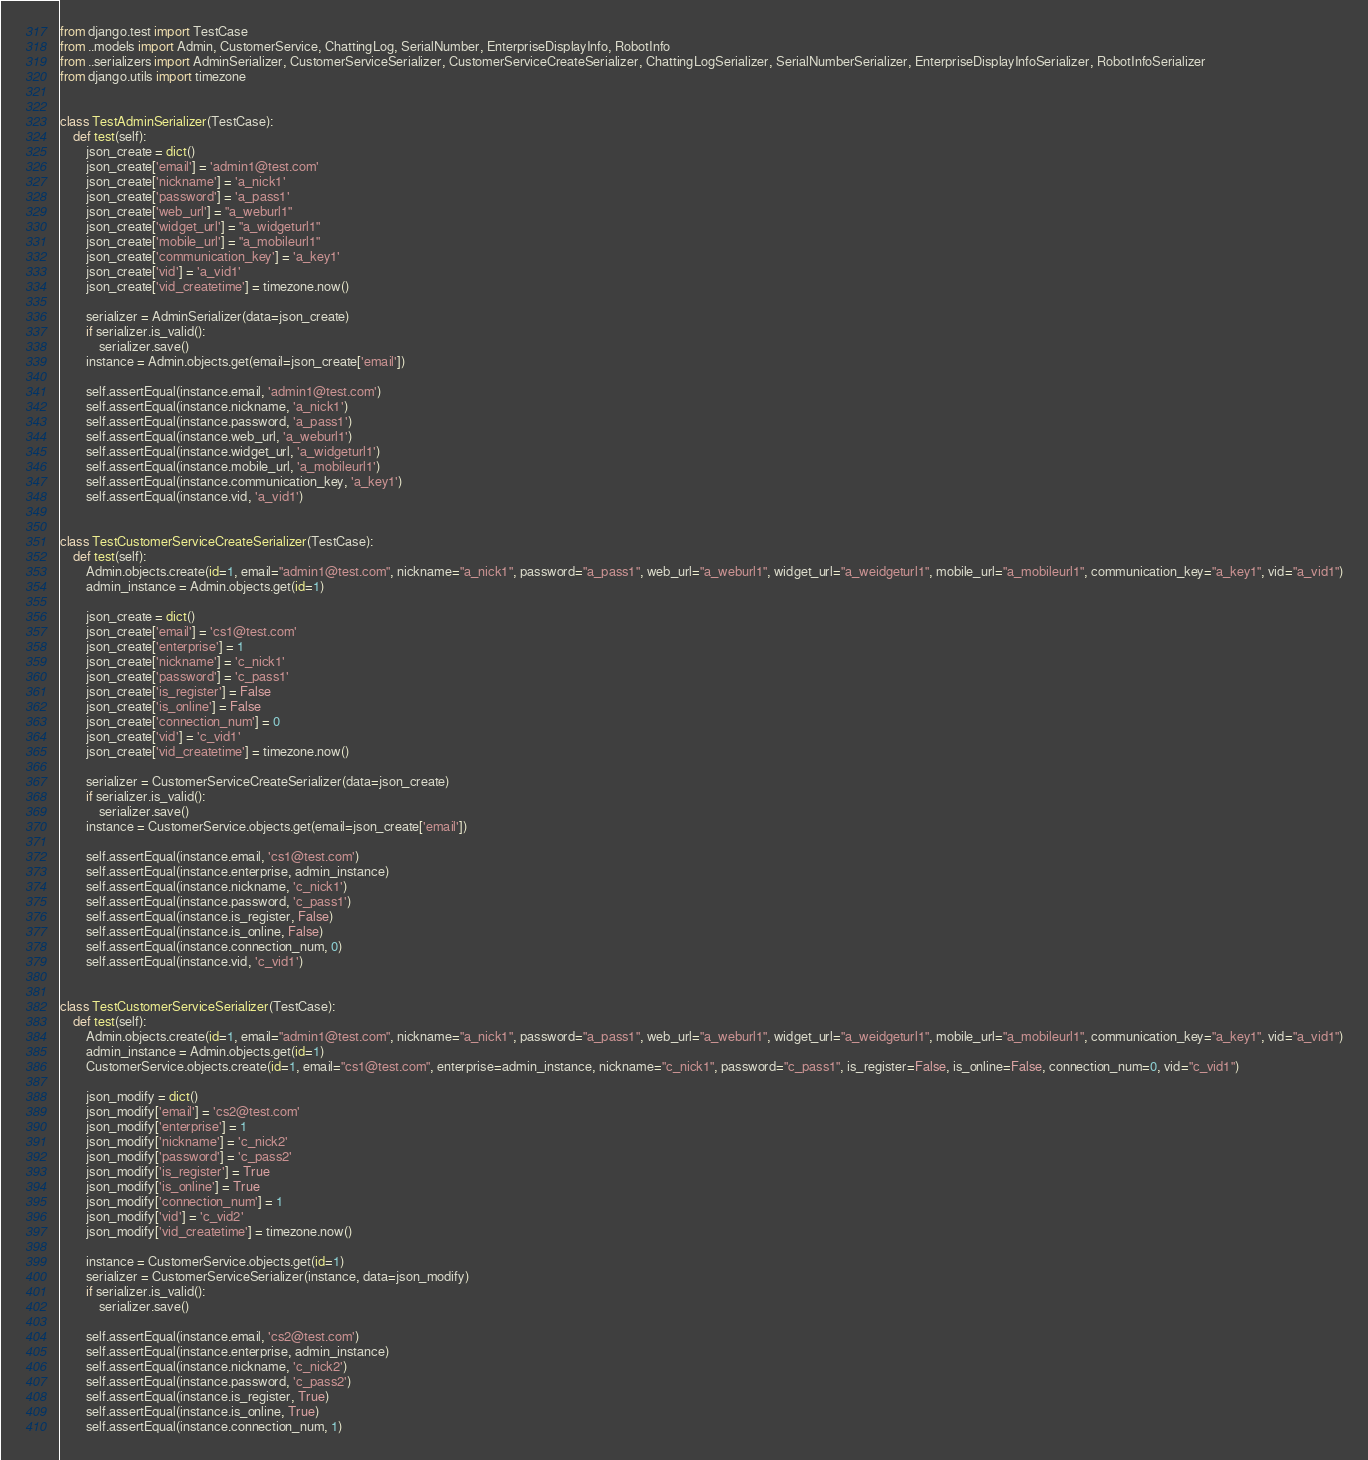<code> <loc_0><loc_0><loc_500><loc_500><_Python_>from django.test import TestCase
from ..models import Admin, CustomerService, ChattingLog, SerialNumber, EnterpriseDisplayInfo, RobotInfo
from ..serializers import AdminSerializer, CustomerServiceSerializer, CustomerServiceCreateSerializer, ChattingLogSerializer, SerialNumberSerializer, EnterpriseDisplayInfoSerializer, RobotInfoSerializer
from django.utils import timezone


class TestAdminSerializer(TestCase):
    def test(self):
        json_create = dict()
        json_create['email'] = 'admin1@test.com'
        json_create['nickname'] = 'a_nick1'
        json_create['password'] = 'a_pass1'
        json_create['web_url'] = "a_weburl1"
        json_create['widget_url'] = "a_widgeturl1"
        json_create['mobile_url'] = "a_mobileurl1"
        json_create['communication_key'] = 'a_key1'
        json_create['vid'] = 'a_vid1'
        json_create['vid_createtime'] = timezone.now()

        serializer = AdminSerializer(data=json_create)
        if serializer.is_valid():
            serializer.save()
        instance = Admin.objects.get(email=json_create['email'])

        self.assertEqual(instance.email, 'admin1@test.com')
        self.assertEqual(instance.nickname, 'a_nick1')
        self.assertEqual(instance.password, 'a_pass1')
        self.assertEqual(instance.web_url, 'a_weburl1')
        self.assertEqual(instance.widget_url, 'a_widgeturl1')
        self.assertEqual(instance.mobile_url, 'a_mobileurl1')
        self.assertEqual(instance.communication_key, 'a_key1')
        self.assertEqual(instance.vid, 'a_vid1')


class TestCustomerServiceCreateSerializer(TestCase):
    def test(self):
        Admin.objects.create(id=1, email="admin1@test.com", nickname="a_nick1", password="a_pass1", web_url="a_weburl1", widget_url="a_weidgeturl1", mobile_url="a_mobileurl1", communication_key="a_key1", vid="a_vid1")
        admin_instance = Admin.objects.get(id=1)

        json_create = dict()
        json_create['email'] = 'cs1@test.com'
        json_create['enterprise'] = 1
        json_create['nickname'] = 'c_nick1'
        json_create['password'] = 'c_pass1'
        json_create['is_register'] = False
        json_create['is_online'] = False
        json_create['connection_num'] = 0
        json_create['vid'] = 'c_vid1'
        json_create['vid_createtime'] = timezone.now()

        serializer = CustomerServiceCreateSerializer(data=json_create)
        if serializer.is_valid():
            serializer.save()
        instance = CustomerService.objects.get(email=json_create['email'])

        self.assertEqual(instance.email, 'cs1@test.com')
        self.assertEqual(instance.enterprise, admin_instance)
        self.assertEqual(instance.nickname, 'c_nick1')
        self.assertEqual(instance.password, 'c_pass1')
        self.assertEqual(instance.is_register, False)
        self.assertEqual(instance.is_online, False)
        self.assertEqual(instance.connection_num, 0)
        self.assertEqual(instance.vid, 'c_vid1')


class TestCustomerServiceSerializer(TestCase):
    def test(self):
        Admin.objects.create(id=1, email="admin1@test.com", nickname="a_nick1", password="a_pass1", web_url="a_weburl1", widget_url="a_weidgeturl1", mobile_url="a_mobileurl1", communication_key="a_key1", vid="a_vid1")
        admin_instance = Admin.objects.get(id=1)
        CustomerService.objects.create(id=1, email="cs1@test.com", enterprise=admin_instance, nickname="c_nick1", password="c_pass1", is_register=False, is_online=False, connection_num=0, vid="c_vid1")

        json_modify = dict()
        json_modify['email'] = 'cs2@test.com'
        json_modify['enterprise'] = 1
        json_modify['nickname'] = 'c_nick2'
        json_modify['password'] = 'c_pass2'
        json_modify['is_register'] = True
        json_modify['is_online'] = True
        json_modify['connection_num'] = 1
        json_modify['vid'] = 'c_vid2'
        json_modify['vid_createtime'] = timezone.now()

        instance = CustomerService.objects.get(id=1)
        serializer = CustomerServiceSerializer(instance, data=json_modify)
        if serializer.is_valid():
            serializer.save()

        self.assertEqual(instance.email, 'cs2@test.com')
        self.assertEqual(instance.enterprise, admin_instance)
        self.assertEqual(instance.nickname, 'c_nick2')
        self.assertEqual(instance.password, 'c_pass2')
        self.assertEqual(instance.is_register, True)
        self.assertEqual(instance.is_online, True)
        self.assertEqual(instance.connection_num, 1)</code> 